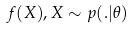Convert formula to latex. <formula><loc_0><loc_0><loc_500><loc_500>f ( X ) , X \sim p ( . | \theta )</formula> 